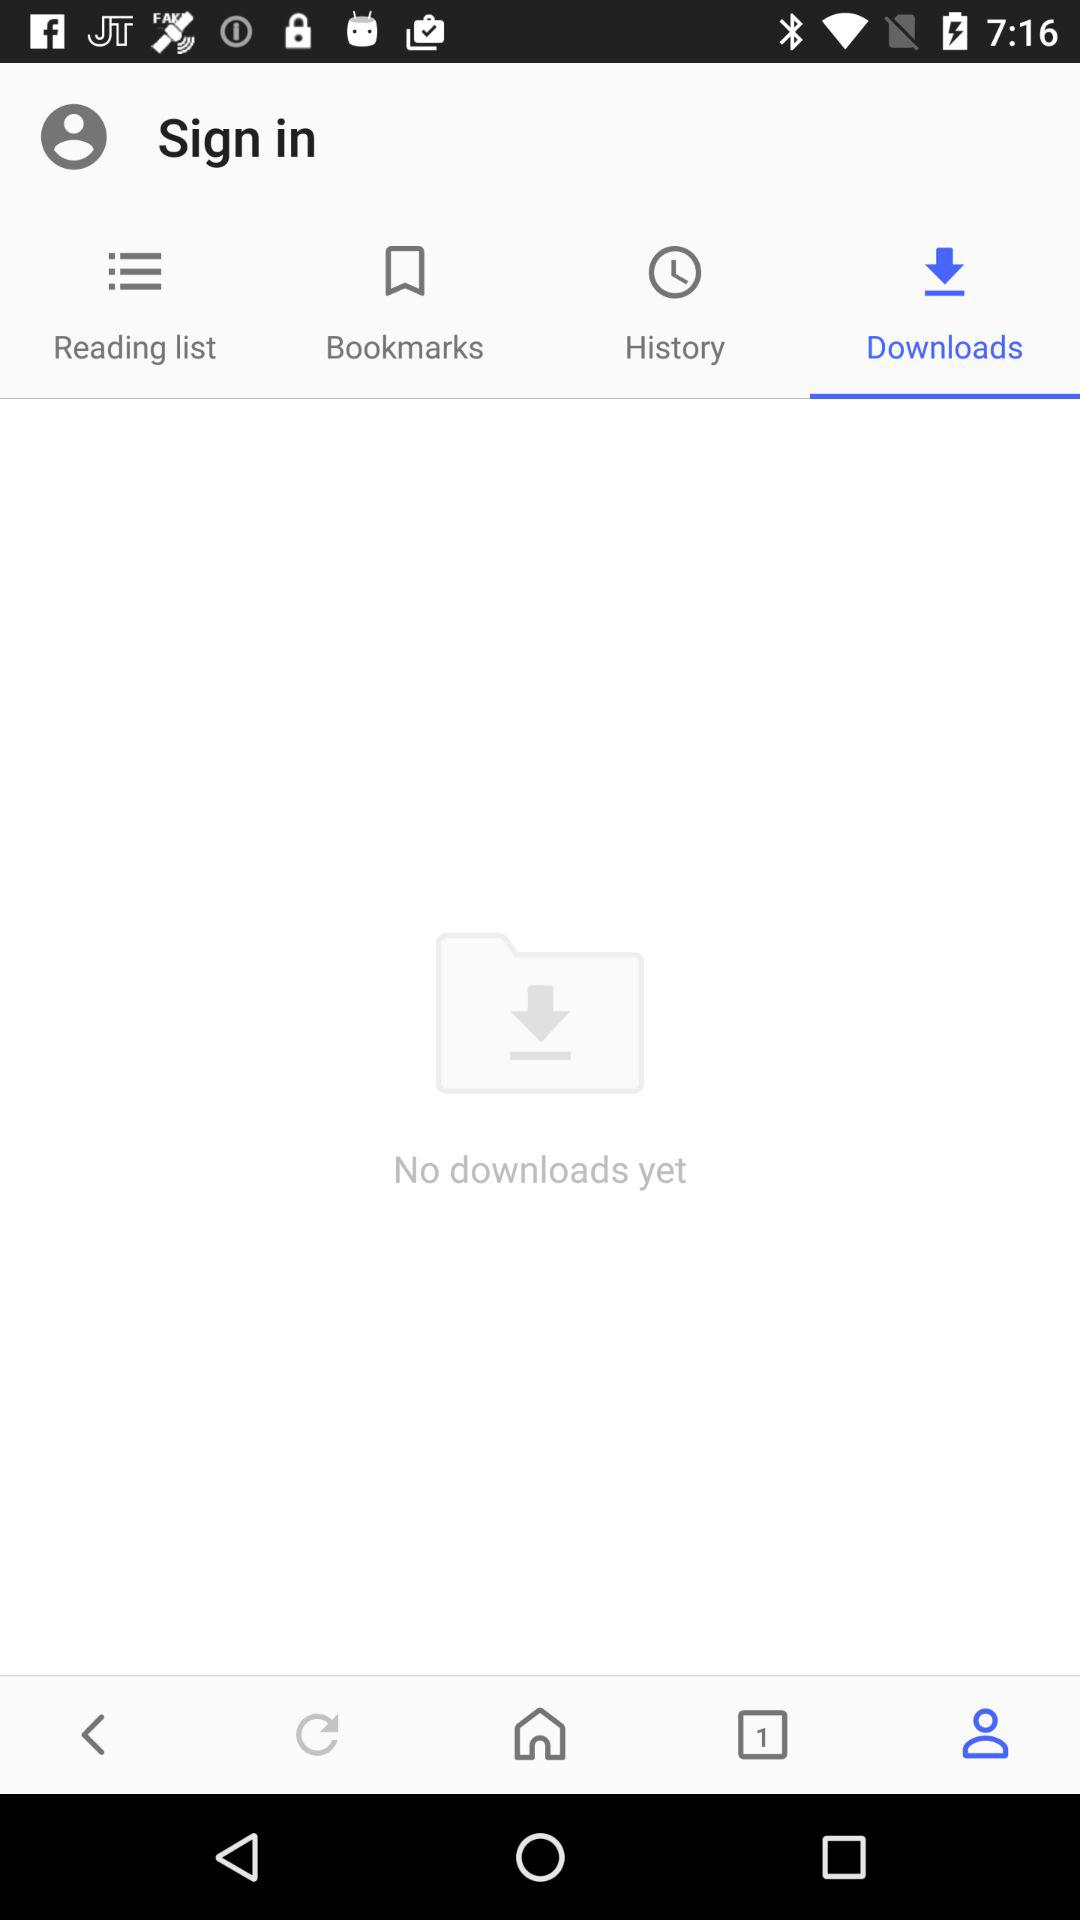How many bookmarks are there?
When the provided information is insufficient, respond with <no answer>. <no answer> 